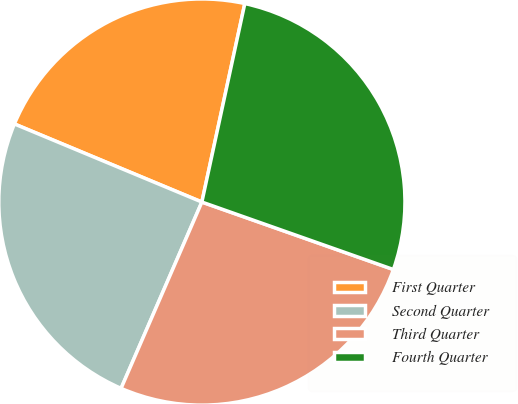Convert chart. <chart><loc_0><loc_0><loc_500><loc_500><pie_chart><fcel>First Quarter<fcel>Second Quarter<fcel>Third Quarter<fcel>Fourth Quarter<nl><fcel>22.11%<fcel>24.77%<fcel>26.12%<fcel>27.0%<nl></chart> 